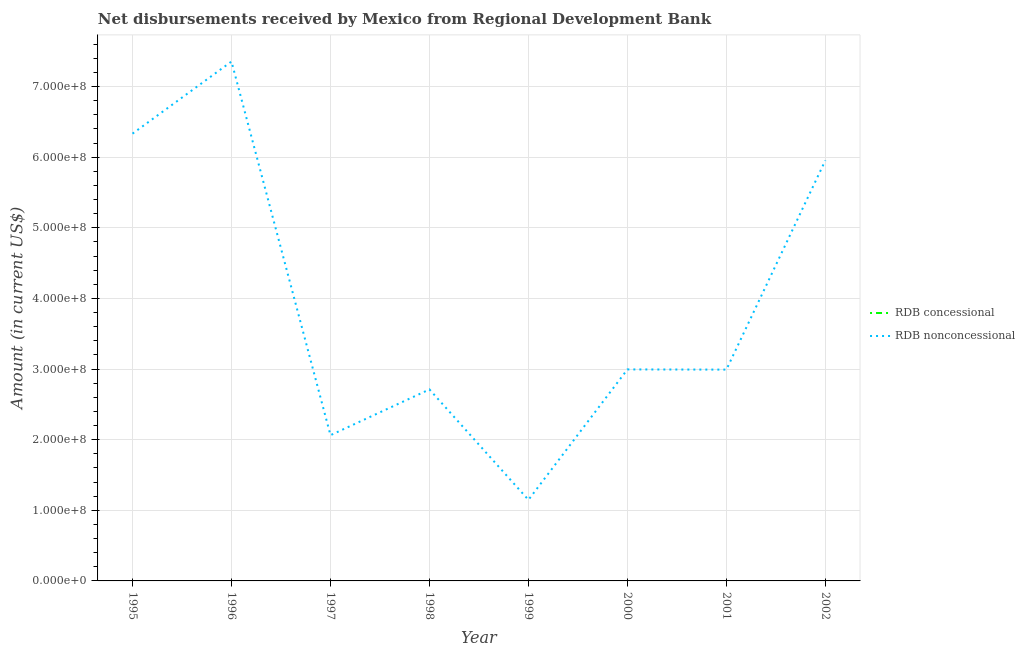Does the line corresponding to net non concessional disbursements from rdb intersect with the line corresponding to net concessional disbursements from rdb?
Your response must be concise. No. What is the net concessional disbursements from rdb in 1996?
Keep it short and to the point. 0. Across all years, what is the maximum net non concessional disbursements from rdb?
Give a very brief answer. 7.35e+08. Across all years, what is the minimum net concessional disbursements from rdb?
Offer a terse response. 0. What is the total net non concessional disbursements from rdb in the graph?
Keep it short and to the point. 3.16e+09. What is the difference between the net non concessional disbursements from rdb in 1999 and that in 2002?
Your answer should be very brief. -4.81e+08. What is the difference between the net non concessional disbursements from rdb in 1996 and the net concessional disbursements from rdb in 2001?
Provide a succinct answer. 7.35e+08. What is the average net non concessional disbursements from rdb per year?
Your answer should be very brief. 3.94e+08. In how many years, is the net concessional disbursements from rdb greater than 180000000 US$?
Offer a very short reply. 0. What is the ratio of the net non concessional disbursements from rdb in 1995 to that in 2000?
Your answer should be compact. 2.11. Is the net non concessional disbursements from rdb in 1996 less than that in 2002?
Give a very brief answer. No. What is the difference between the highest and the second highest net non concessional disbursements from rdb?
Provide a short and direct response. 1.02e+08. What is the difference between the highest and the lowest net non concessional disbursements from rdb?
Offer a very short reply. 6.21e+08. In how many years, is the net non concessional disbursements from rdb greater than the average net non concessional disbursements from rdb taken over all years?
Keep it short and to the point. 3. Does the net non concessional disbursements from rdb monotonically increase over the years?
Keep it short and to the point. No. Is the net non concessional disbursements from rdb strictly greater than the net concessional disbursements from rdb over the years?
Give a very brief answer. Yes. How many years are there in the graph?
Keep it short and to the point. 8. Are the values on the major ticks of Y-axis written in scientific E-notation?
Ensure brevity in your answer.  Yes. Where does the legend appear in the graph?
Provide a short and direct response. Center right. How many legend labels are there?
Make the answer very short. 2. How are the legend labels stacked?
Your response must be concise. Vertical. What is the title of the graph?
Provide a short and direct response. Net disbursements received by Mexico from Regional Development Bank. Does "Short-term debt" appear as one of the legend labels in the graph?
Give a very brief answer. No. What is the Amount (in current US$) of RDB nonconcessional in 1995?
Your answer should be compact. 6.33e+08. What is the Amount (in current US$) in RDB concessional in 1996?
Offer a very short reply. 0. What is the Amount (in current US$) of RDB nonconcessional in 1996?
Offer a terse response. 7.35e+08. What is the Amount (in current US$) in RDB nonconcessional in 1997?
Offer a very short reply. 2.06e+08. What is the Amount (in current US$) of RDB concessional in 1998?
Your response must be concise. 0. What is the Amount (in current US$) of RDB nonconcessional in 1998?
Offer a very short reply. 2.71e+08. What is the Amount (in current US$) of RDB concessional in 1999?
Your answer should be compact. 0. What is the Amount (in current US$) of RDB nonconcessional in 1999?
Keep it short and to the point. 1.15e+08. What is the Amount (in current US$) of RDB nonconcessional in 2000?
Keep it short and to the point. 2.99e+08. What is the Amount (in current US$) in RDB concessional in 2001?
Make the answer very short. 0. What is the Amount (in current US$) of RDB nonconcessional in 2001?
Provide a short and direct response. 2.99e+08. What is the Amount (in current US$) of RDB nonconcessional in 2002?
Your answer should be compact. 5.96e+08. Across all years, what is the maximum Amount (in current US$) of RDB nonconcessional?
Make the answer very short. 7.35e+08. Across all years, what is the minimum Amount (in current US$) in RDB nonconcessional?
Offer a very short reply. 1.15e+08. What is the total Amount (in current US$) of RDB nonconcessional in the graph?
Keep it short and to the point. 3.16e+09. What is the difference between the Amount (in current US$) in RDB nonconcessional in 1995 and that in 1996?
Keep it short and to the point. -1.02e+08. What is the difference between the Amount (in current US$) of RDB nonconcessional in 1995 and that in 1997?
Ensure brevity in your answer.  4.27e+08. What is the difference between the Amount (in current US$) of RDB nonconcessional in 1995 and that in 1998?
Offer a terse response. 3.62e+08. What is the difference between the Amount (in current US$) of RDB nonconcessional in 1995 and that in 1999?
Your answer should be compact. 5.19e+08. What is the difference between the Amount (in current US$) of RDB nonconcessional in 1995 and that in 2000?
Keep it short and to the point. 3.34e+08. What is the difference between the Amount (in current US$) of RDB nonconcessional in 1995 and that in 2001?
Make the answer very short. 3.34e+08. What is the difference between the Amount (in current US$) in RDB nonconcessional in 1995 and that in 2002?
Provide a succinct answer. 3.79e+07. What is the difference between the Amount (in current US$) of RDB nonconcessional in 1996 and that in 1997?
Offer a terse response. 5.29e+08. What is the difference between the Amount (in current US$) in RDB nonconcessional in 1996 and that in 1998?
Provide a short and direct response. 4.64e+08. What is the difference between the Amount (in current US$) of RDB nonconcessional in 1996 and that in 1999?
Make the answer very short. 6.21e+08. What is the difference between the Amount (in current US$) of RDB nonconcessional in 1996 and that in 2000?
Provide a succinct answer. 4.36e+08. What is the difference between the Amount (in current US$) of RDB nonconcessional in 1996 and that in 2001?
Ensure brevity in your answer.  4.36e+08. What is the difference between the Amount (in current US$) in RDB nonconcessional in 1996 and that in 2002?
Keep it short and to the point. 1.40e+08. What is the difference between the Amount (in current US$) in RDB nonconcessional in 1997 and that in 1998?
Give a very brief answer. -6.48e+07. What is the difference between the Amount (in current US$) of RDB nonconcessional in 1997 and that in 1999?
Offer a terse response. 9.15e+07. What is the difference between the Amount (in current US$) in RDB nonconcessional in 1997 and that in 2000?
Keep it short and to the point. -9.31e+07. What is the difference between the Amount (in current US$) of RDB nonconcessional in 1997 and that in 2001?
Ensure brevity in your answer.  -9.29e+07. What is the difference between the Amount (in current US$) in RDB nonconcessional in 1997 and that in 2002?
Your answer should be compact. -3.89e+08. What is the difference between the Amount (in current US$) in RDB nonconcessional in 1998 and that in 1999?
Offer a terse response. 1.56e+08. What is the difference between the Amount (in current US$) of RDB nonconcessional in 1998 and that in 2000?
Offer a very short reply. -2.83e+07. What is the difference between the Amount (in current US$) in RDB nonconcessional in 1998 and that in 2001?
Offer a very short reply. -2.81e+07. What is the difference between the Amount (in current US$) in RDB nonconcessional in 1998 and that in 2002?
Ensure brevity in your answer.  -3.24e+08. What is the difference between the Amount (in current US$) in RDB nonconcessional in 1999 and that in 2000?
Your answer should be compact. -1.85e+08. What is the difference between the Amount (in current US$) in RDB nonconcessional in 1999 and that in 2001?
Give a very brief answer. -1.84e+08. What is the difference between the Amount (in current US$) in RDB nonconcessional in 1999 and that in 2002?
Offer a very short reply. -4.81e+08. What is the difference between the Amount (in current US$) in RDB nonconcessional in 2000 and that in 2001?
Make the answer very short. 2.70e+05. What is the difference between the Amount (in current US$) of RDB nonconcessional in 2000 and that in 2002?
Provide a succinct answer. -2.96e+08. What is the difference between the Amount (in current US$) of RDB nonconcessional in 2001 and that in 2002?
Give a very brief answer. -2.96e+08. What is the average Amount (in current US$) in RDB concessional per year?
Offer a very short reply. 0. What is the average Amount (in current US$) in RDB nonconcessional per year?
Your response must be concise. 3.94e+08. What is the ratio of the Amount (in current US$) in RDB nonconcessional in 1995 to that in 1996?
Give a very brief answer. 0.86. What is the ratio of the Amount (in current US$) of RDB nonconcessional in 1995 to that in 1997?
Make the answer very short. 3.07. What is the ratio of the Amount (in current US$) in RDB nonconcessional in 1995 to that in 1998?
Your answer should be very brief. 2.34. What is the ratio of the Amount (in current US$) of RDB nonconcessional in 1995 to that in 1999?
Offer a very short reply. 5.52. What is the ratio of the Amount (in current US$) of RDB nonconcessional in 1995 to that in 2000?
Offer a very short reply. 2.11. What is the ratio of the Amount (in current US$) in RDB nonconcessional in 1995 to that in 2001?
Ensure brevity in your answer.  2.12. What is the ratio of the Amount (in current US$) of RDB nonconcessional in 1995 to that in 2002?
Ensure brevity in your answer.  1.06. What is the ratio of the Amount (in current US$) in RDB nonconcessional in 1996 to that in 1997?
Your response must be concise. 3.56. What is the ratio of the Amount (in current US$) of RDB nonconcessional in 1996 to that in 1998?
Make the answer very short. 2.71. What is the ratio of the Amount (in current US$) in RDB nonconcessional in 1996 to that in 1999?
Keep it short and to the point. 6.41. What is the ratio of the Amount (in current US$) of RDB nonconcessional in 1996 to that in 2000?
Give a very brief answer. 2.46. What is the ratio of the Amount (in current US$) of RDB nonconcessional in 1996 to that in 2001?
Your response must be concise. 2.46. What is the ratio of the Amount (in current US$) of RDB nonconcessional in 1996 to that in 2002?
Offer a terse response. 1.24. What is the ratio of the Amount (in current US$) in RDB nonconcessional in 1997 to that in 1998?
Make the answer very short. 0.76. What is the ratio of the Amount (in current US$) of RDB nonconcessional in 1997 to that in 1999?
Your answer should be compact. 1.8. What is the ratio of the Amount (in current US$) in RDB nonconcessional in 1997 to that in 2000?
Ensure brevity in your answer.  0.69. What is the ratio of the Amount (in current US$) in RDB nonconcessional in 1997 to that in 2001?
Give a very brief answer. 0.69. What is the ratio of the Amount (in current US$) in RDB nonconcessional in 1997 to that in 2002?
Provide a succinct answer. 0.35. What is the ratio of the Amount (in current US$) in RDB nonconcessional in 1998 to that in 1999?
Offer a very short reply. 2.36. What is the ratio of the Amount (in current US$) of RDB nonconcessional in 1998 to that in 2000?
Provide a short and direct response. 0.91. What is the ratio of the Amount (in current US$) in RDB nonconcessional in 1998 to that in 2001?
Your response must be concise. 0.91. What is the ratio of the Amount (in current US$) in RDB nonconcessional in 1998 to that in 2002?
Keep it short and to the point. 0.46. What is the ratio of the Amount (in current US$) in RDB nonconcessional in 1999 to that in 2000?
Provide a succinct answer. 0.38. What is the ratio of the Amount (in current US$) of RDB nonconcessional in 1999 to that in 2001?
Ensure brevity in your answer.  0.38. What is the ratio of the Amount (in current US$) in RDB nonconcessional in 1999 to that in 2002?
Offer a very short reply. 0.19. What is the ratio of the Amount (in current US$) of RDB nonconcessional in 2000 to that in 2001?
Your answer should be compact. 1. What is the ratio of the Amount (in current US$) of RDB nonconcessional in 2000 to that in 2002?
Ensure brevity in your answer.  0.5. What is the ratio of the Amount (in current US$) of RDB nonconcessional in 2001 to that in 2002?
Offer a very short reply. 0.5. What is the difference between the highest and the second highest Amount (in current US$) in RDB nonconcessional?
Keep it short and to the point. 1.02e+08. What is the difference between the highest and the lowest Amount (in current US$) of RDB nonconcessional?
Your answer should be compact. 6.21e+08. 